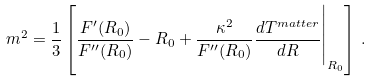Convert formula to latex. <formula><loc_0><loc_0><loc_500><loc_500>m ^ { 2 } = \frac { 1 } { 3 } \left [ \frac { F ^ { \prime } ( R _ { 0 } ) } { F ^ { \prime \prime } ( R _ { 0 } ) } - R _ { 0 } + \frac { \kappa ^ { 2 } } { F ^ { \prime \prime } ( R _ { 0 } ) } \frac { d T ^ { m a t t e r } } { d R } \Big | _ { R _ { 0 } } \right ] \, .</formula> 